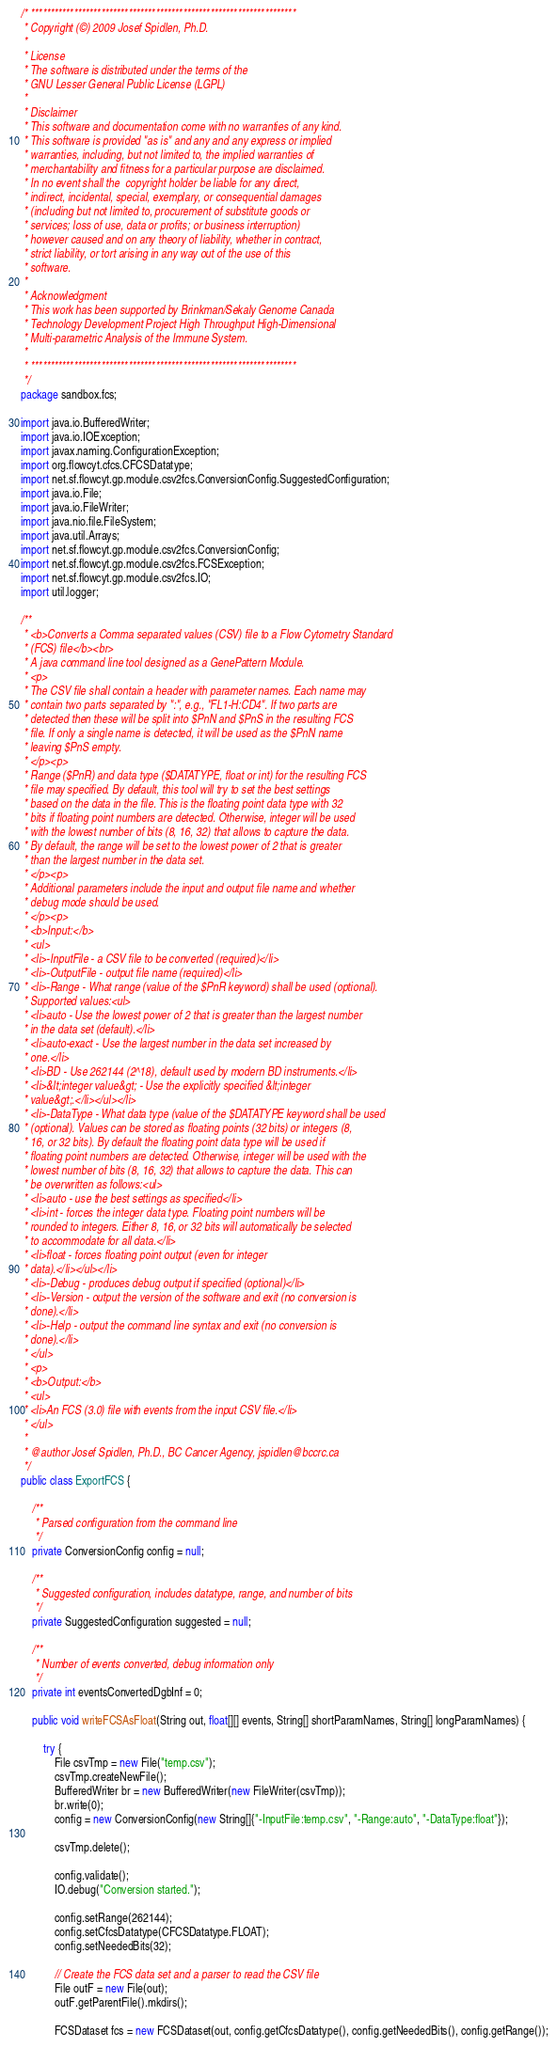Convert code to text. <code><loc_0><loc_0><loc_500><loc_500><_Java_>/* ********************************************************************
 * Copyright (©) 2009 Josef Spidlen, Ph.D.
 * 
 * License
 * The software is distributed under the terms of the 
 * GNU Lesser General Public License (LGPL)
 * 
 * Disclaimer
 * This software and documentation come with no warranties of any kind.
 * This software is provided "as is" and any and any express or implied 
 * warranties, including, but not limited to, the implied warranties of
 * merchantability and fitness for a particular purpose are disclaimed.
 * In no event shall the  copyright holder be liable for any direct, 
 * indirect, incidental, special, exemplary, or consequential damages
 * (including but not limited to, procurement of substitute goods or 
 * services; loss of use, data or profits; or business interruption)
 * however caused and on any theory of liability, whether in contract,
 * strict liability, or tort arising in any way out of the use of this 
 * software.    
 *  
 * Acknowledgment
 * This work has been supported by Brinkman/Sekaly Genome Canada 
 * Technology Development Project High Throughput High-Dimensional 
 * Multi-parametric Analysis of the Immune System.
 * 
 * ******************************************************************** 
 */
package sandbox.fcs;

import java.io.BufferedWriter;
import java.io.IOException;
import javax.naming.ConfigurationException;
import org.flowcyt.cfcs.CFCSDatatype;
import net.sf.flowcyt.gp.module.csv2fcs.ConversionConfig.SuggestedConfiguration;
import java.io.File;
import java.io.FileWriter;
import java.nio.file.FileSystem;
import java.util.Arrays;
import net.sf.flowcyt.gp.module.csv2fcs.ConversionConfig;
import net.sf.flowcyt.gp.module.csv2fcs.FCSException;
import net.sf.flowcyt.gp.module.csv2fcs.IO;
import util.logger;

/**
 * <b>Converts a Comma separated values (CSV) file to a Flow Cytometry Standard
 * (FCS) file</b><br>
 * A java command line tool designed as a GenePattern Module.
 * <p>
 * The CSV file shall contain a header with parameter names. Each name may
 * contain two parts separated by ":", e.g., "FL1-H:CD4". If two parts are
 * detected then these will be split into $PnN and $PnS in the resulting FCS
 * file. If only a single name is detected, it will be used as the $PnN name
 * leaving $PnS empty.
 * </p><p>
 * Range ($PnR) and data type ($DATATYPE, float or int) for the resulting FCS
 * file may specified. By default, this tool will try to set the best settings
 * based on the data in the file. This is the floating point data type with 32
 * bits if floating point numbers are detected. Otherwise, integer will be used
 * with the lowest number of bits (8, 16, 32) that allows to capture the data.
 * By default, the range will be set to the lowest power of 2 that is greater
 * than the largest number in the data set.
 * </p><p>
 * Additional parameters include the input and output file name and whether
 * debug mode should be used.
 * </p><p>
 * <b>Input:</b>
 * <ul>
 * <li>-InputFile - a CSV file to be converted (required)</li>
 * <li>-OutputFile - output file name (required)</li>
 * <li>-Range - What range (value of the $PnR keyword) shall be used (optional).
 * Supported values:<ul>
 * <li>auto - Use the lowest power of 2 that is greater than the largest number
 * in the data set (default).</li>
 * <li>auto-exact - Use the largest number in the data set increased by
 * one.</li>
 * <li>BD - Use 262144 (2^18), default used by modern BD instruments.</li>
 * <li>&lt;integer value&gt; - Use the explicitly specified &lt;integer
 * value&gt;.</li></ul></li>
 * <li>-DataType - What data type (value of the $DATATYPE keyword shall be used
 * (optional). Values can be stored as floating points (32 bits) or integers (8,
 * 16, or 32 bits). By default the floating point data type will be used if
 * floating point numbers are detected. Otherwise, integer will be used with the
 * lowest number of bits (8, 16, 32) that allows to capture the data. This can
 * be overwritten as follows:<ul>
 * <li>auto - use the best settings as specified</li>
 * <li>int - forces the integer data type. Floating point numbers will be
 * rounded to integers. Either 8, 16, or 32 bits will automatically be selected
 * to accommodate for all data.</li>
 * <li>float - forces floating point output (even for integer
 * data).</li></ul></li>
 * <li>-Debug - produces debug output if specified (optional)</li>
 * <li>-Version - output the version of the software and exit (no conversion is
 * done).</li>
 * <li>-Help - output the command line syntax and exit (no conversion is
 * done).</li>
 * </ul>
 * <p>
 * <b>Output:</b>
 * <ul>
 * <li>An FCS (3.0) file with events from the input CSV file.</li>
 * </ul>
 *
 * @author Josef Spidlen, Ph.D., BC Cancer Agency, jspidlen@bccrc.ca
 */
public class ExportFCS {

    /**
     * Parsed configuration from the command line
     */
    private ConversionConfig config = null;

    /**
     * Suggested configuration, includes datatype, range, and number of bits
     */
    private SuggestedConfiguration suggested = null;

    /**
     * Number of events converted, debug information only
     */
    private int eventsConvertedDgbInf = 0;

    public void writeFCSAsFloat(String out, float[][] events, String[] shortParamNames, String[] longParamNames) {

        try {
            File csvTmp = new File("temp.csv");
            csvTmp.createNewFile();
            BufferedWriter br = new BufferedWriter(new FileWriter(csvTmp));
            br.write(0);
            config = new ConversionConfig(new String[]{"-InputFile:temp.csv", "-Range:auto", "-DataType:float"});

            csvTmp.delete();

            config.validate();
            IO.debug("Conversion started.");

            config.setRange(262144);
            config.setCfcsDatatype(CFCSDatatype.FLOAT);
            config.setNeededBits(32);

            // Create the FCS data set and a parser to read the CSV file
            File outF = new File(out);
            outF.getParentFile().mkdirs();

            FCSDataset fcs = new FCSDataset(out, config.getCfcsDatatype(), config.getNeededBits(), config.getRange());
</code> 